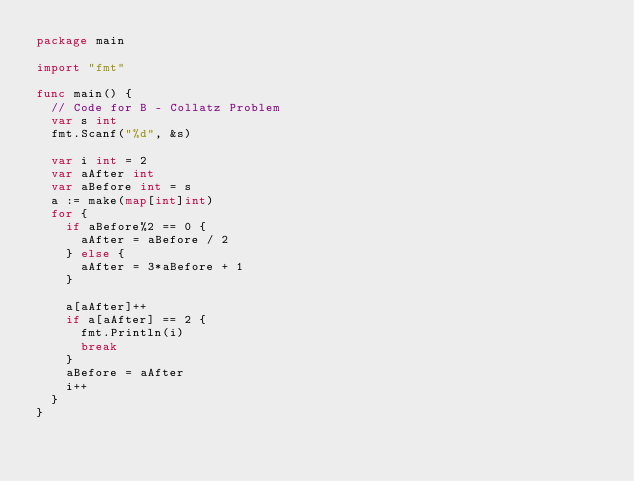<code> <loc_0><loc_0><loc_500><loc_500><_Go_>package main

import "fmt"

func main() {
	// Code for B - Collatz Problem
	var s int
	fmt.Scanf("%d", &s)

	var i int = 2
	var aAfter int
	var aBefore int = s
	a := make(map[int]int)
	for {
		if aBefore%2 == 0 {
			aAfter = aBefore / 2
		} else {
			aAfter = 3*aBefore + 1
		}

		a[aAfter]++
		if a[aAfter] == 2 {
			fmt.Println(i)
			break
		}
		aBefore = aAfter
		i++
	}
}
</code> 